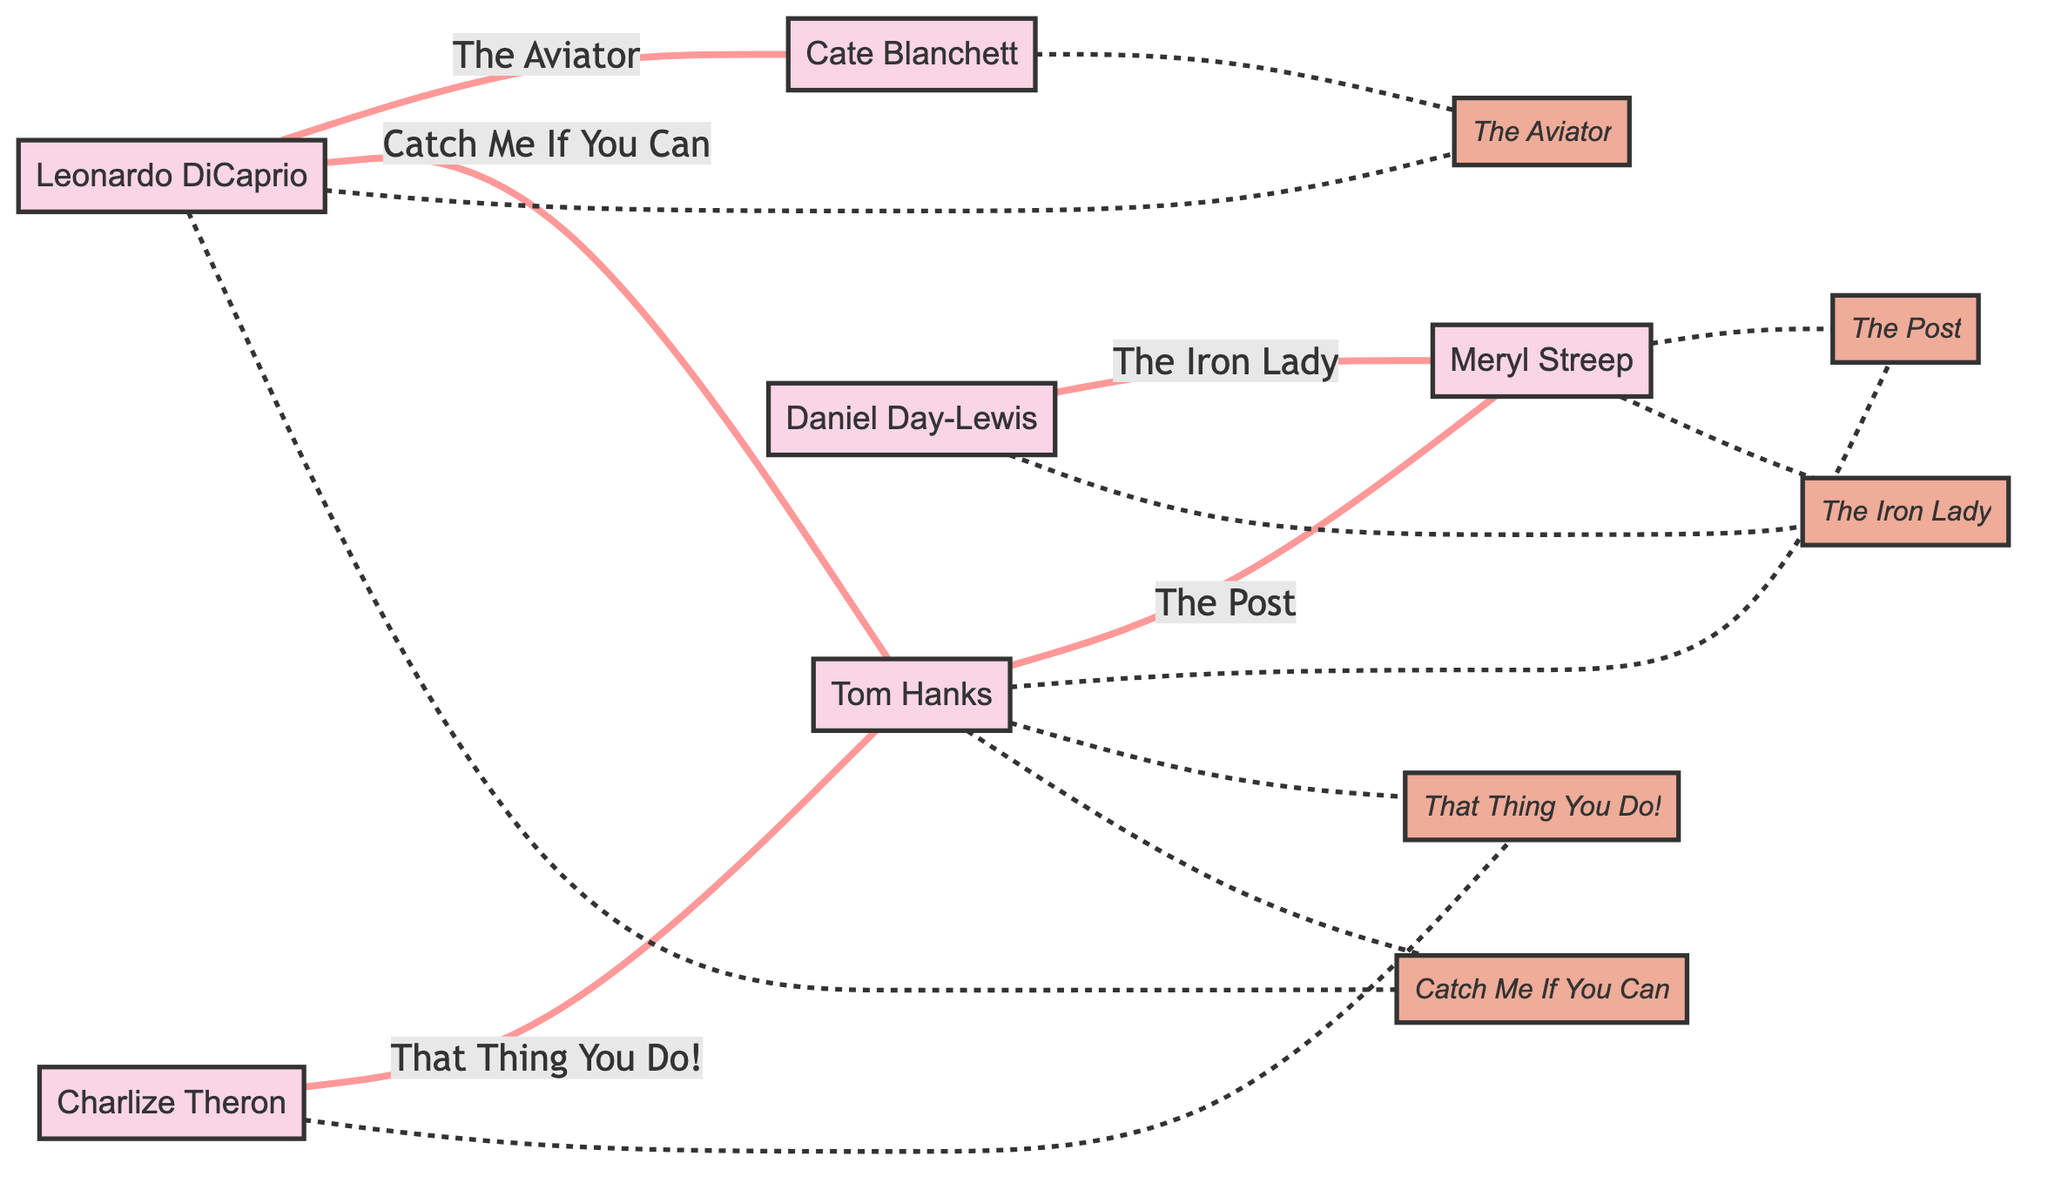What actors are connected by "The Post"? The edge labeled "The Post" connects Tom Hanks and Meryl Streep.
Answer: Tom Hanks, Meryl Streep How many actors are in the diagram? By counting the nodes listed, there are six distinct actors connected by various edges.
Answer: 6 Who plays "Frank Abagnale Jr."? The edge labeled "Catch Me If You Can" indicates that Leonardo DiCaprio plays the role of Frank Abagnale Jr.
Answer: Leonardo DiCaprio Which actors shared "The Iron Lady"? The edge labeled "The Iron Lady" connects Daniel Day-Lewis and Meryl Streep.
Answer: Daniel Day-Lewis, Meryl Streep What role does Tom Hanks play in "That Thing You Do!"? According to the edge labeled "That Thing You Do!", Tom Hanks plays the role of Mr. White.
Answer: Mr. White How many movies are shared between Tom Hanks and Leonardo DiCaprio? The edges indicate two movies, "Catch Me If You Can" and "That Thing You Do!" are shared between them.
Answer: 2 Which actress plays "Katharine Hepburn"? The edge labeled "The Aviator" shows that Cate Blanchett plays Katharine Hepburn.
Answer: Cate Blanchett What is the connection between Daniel Day-Lewis and Meryl Streep? They are connected by the shared movie "The Iron Lady", where Daniel Day-Lewis plays Denis Thatcher and Meryl Streep plays Margaret Thatcher.
Answer: The Iron Lady Which movie links Charlize Theron and Tom Hanks? The edge labeled "That Thing You Do!" shows this connection.
Answer: That Thing You Do! 